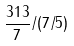Convert formula to latex. <formula><loc_0><loc_0><loc_500><loc_500>\frac { 3 1 3 } { 7 } / ( 7 / 5 )</formula> 